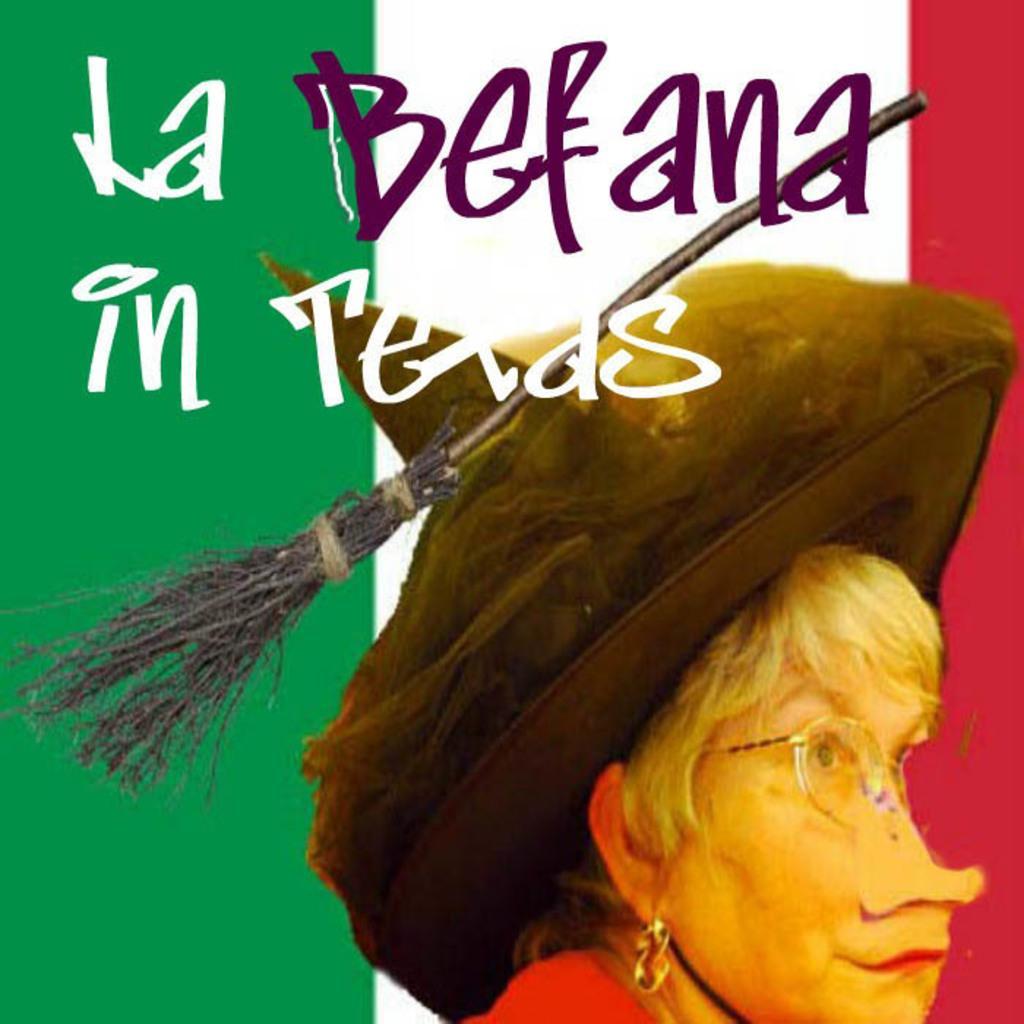Please provide a concise description of this image. This is a poster of a lady wearing specs, hat. On the hat there is a broomstick. On the image something is written. 